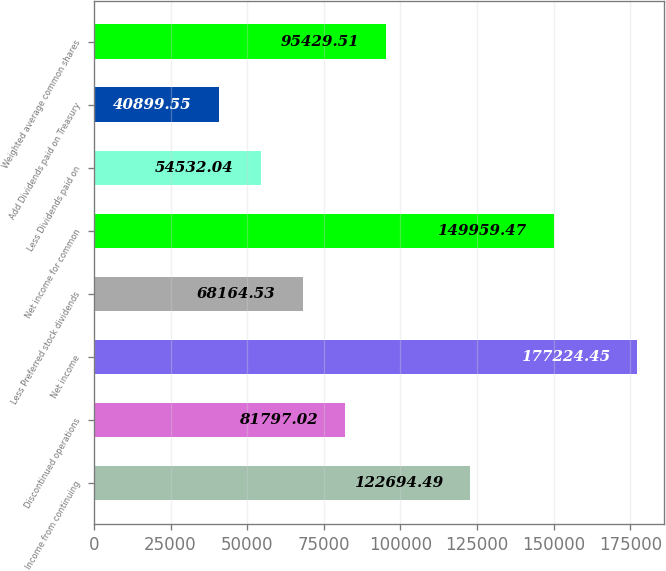Convert chart. <chart><loc_0><loc_0><loc_500><loc_500><bar_chart><fcel>Income from continuing<fcel>Discontinued operations<fcel>Net income<fcel>Less Preferred stock dividends<fcel>Net income for common<fcel>Less Dividends paid on<fcel>Add Dividends paid on Treasury<fcel>Weighted average common shares<nl><fcel>122694<fcel>81797<fcel>177224<fcel>68164.5<fcel>149959<fcel>54532<fcel>40899.6<fcel>95429.5<nl></chart> 